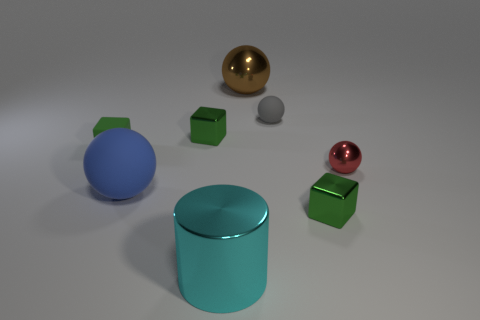Are there an equal number of blue rubber things that are behind the brown metal object and small green metallic blocks?
Your answer should be compact. No. What is the size of the brown ball?
Your answer should be very brief. Large. There is a tiny shiny block that is left of the small rubber ball; how many green metallic objects are in front of it?
Provide a short and direct response. 1. There is a metallic object that is both behind the cyan object and left of the big brown shiny sphere; what is its shape?
Keep it short and to the point. Cube. What number of big balls are the same color as the tiny shiny ball?
Give a very brief answer. 0. Is there a block that is on the left side of the tiny object to the left of the rubber thing that is in front of the tiny green matte thing?
Your answer should be very brief. No. How big is the ball that is both right of the large cyan cylinder and in front of the tiny gray matte thing?
Provide a succinct answer. Small. How many other small things have the same material as the blue object?
Provide a succinct answer. 2. What number of balls are either small gray rubber objects or cyan objects?
Your answer should be compact. 1. What is the size of the shiny cube right of the small metal object to the left of the small rubber thing on the right side of the large brown metallic thing?
Make the answer very short. Small. 